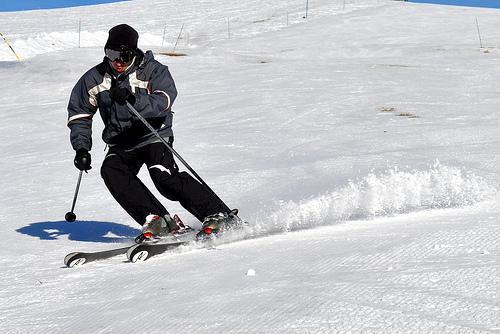How many people are visible?
Give a very brief answer. 1. 